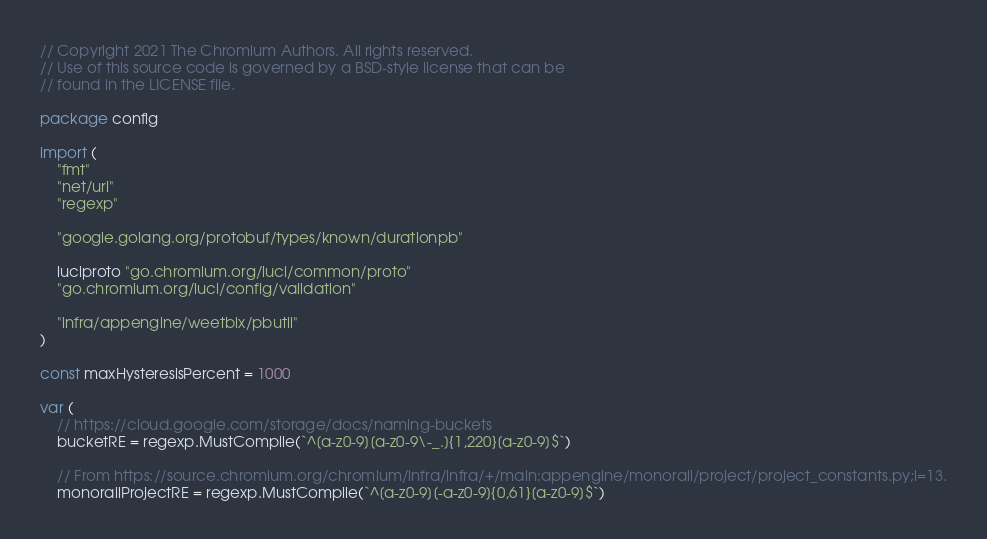<code> <loc_0><loc_0><loc_500><loc_500><_Go_>// Copyright 2021 The Chromium Authors. All rights reserved.
// Use of this source code is governed by a BSD-style license that can be
// found in the LICENSE file.

package config

import (
	"fmt"
	"net/url"
	"regexp"

	"google.golang.org/protobuf/types/known/durationpb"

	luciproto "go.chromium.org/luci/common/proto"
	"go.chromium.org/luci/config/validation"

	"infra/appengine/weetbix/pbutil"
)

const maxHysteresisPercent = 1000

var (
	// https://cloud.google.com/storage/docs/naming-buckets
	bucketRE = regexp.MustCompile(`^[a-z0-9][a-z0-9\-_.]{1,220}[a-z0-9]$`)

	// From https://source.chromium.org/chromium/infra/infra/+/main:appengine/monorail/project/project_constants.py;l=13.
	monorailProjectRE = regexp.MustCompile(`^[a-z0-9][-a-z0-9]{0,61}[a-z0-9]$`)
</code> 